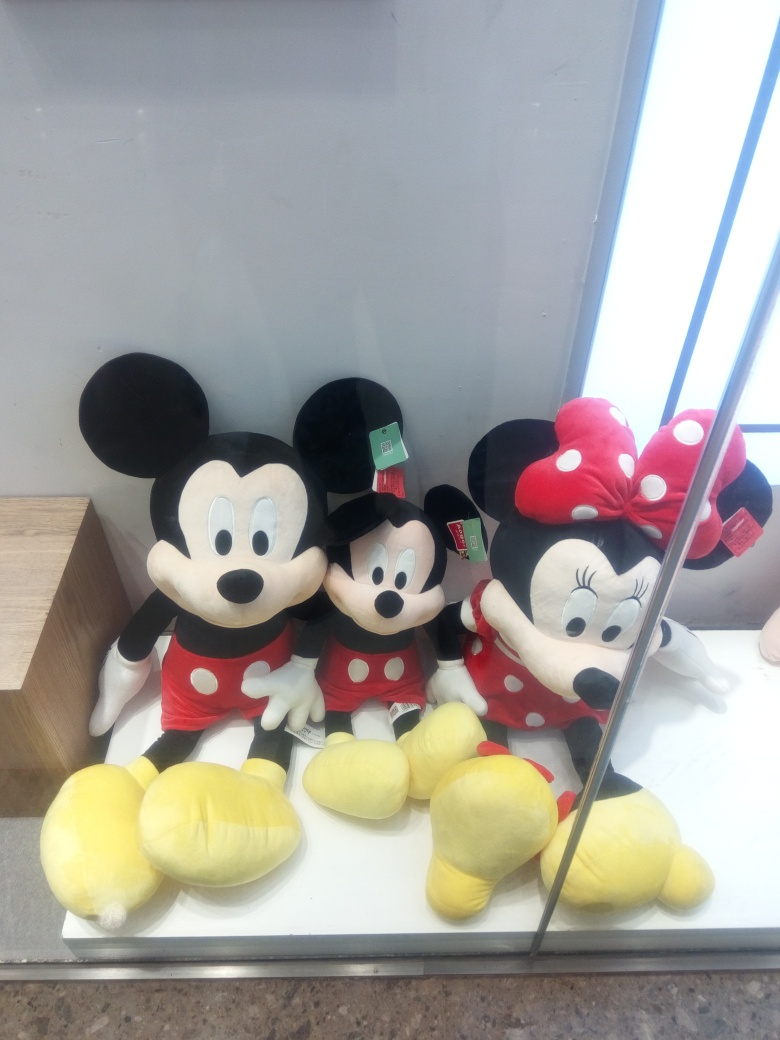Are these plush toys intended for children or adults? These plush toys are versatile and can appeal to a broad audience. While they are safe and suitable for children to play with, adults who are collectors or Disney enthusiasts may also be interested in them for collection purposes or as a nostalgic reminder of their favorite animated characters. What could be the significance of having a plush toy? Plush toys can hold different significance for people. For children, they can be a source of comfort and a cherished plaything. For adults, they might represent a connection to favorite stories or characters from their childhood, serving as a beloved collectible or a decorative item that brings joy and a touch of whimsy to their living space. 